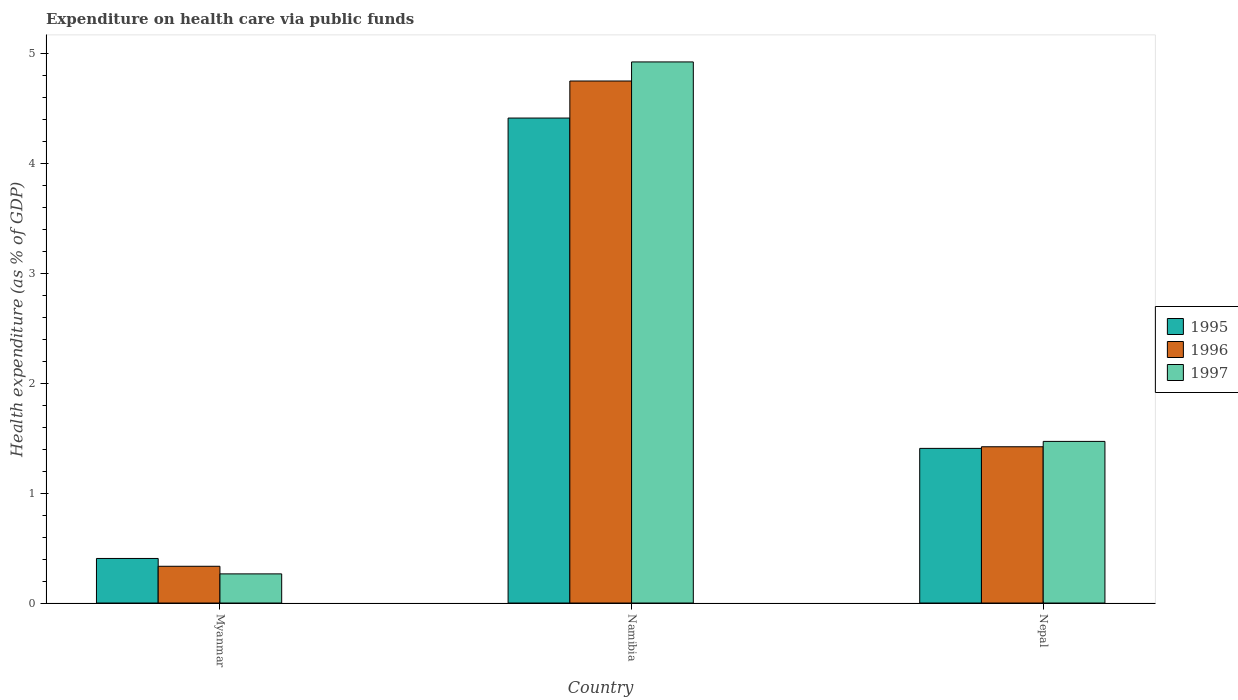Are the number of bars on each tick of the X-axis equal?
Ensure brevity in your answer.  Yes. How many bars are there on the 3rd tick from the right?
Your answer should be compact. 3. What is the label of the 1st group of bars from the left?
Your response must be concise. Myanmar. What is the expenditure made on health care in 1997 in Nepal?
Ensure brevity in your answer.  1.47. Across all countries, what is the maximum expenditure made on health care in 1996?
Make the answer very short. 4.75. Across all countries, what is the minimum expenditure made on health care in 1996?
Ensure brevity in your answer.  0.33. In which country was the expenditure made on health care in 1997 maximum?
Provide a succinct answer. Namibia. In which country was the expenditure made on health care in 1996 minimum?
Your answer should be compact. Myanmar. What is the total expenditure made on health care in 1995 in the graph?
Ensure brevity in your answer.  6.23. What is the difference between the expenditure made on health care in 1997 in Myanmar and that in Nepal?
Offer a very short reply. -1.21. What is the difference between the expenditure made on health care in 1995 in Nepal and the expenditure made on health care in 1996 in Myanmar?
Make the answer very short. 1.07. What is the average expenditure made on health care in 1996 per country?
Offer a terse response. 2.17. What is the difference between the expenditure made on health care of/in 1995 and expenditure made on health care of/in 1997 in Nepal?
Provide a succinct answer. -0.06. In how many countries, is the expenditure made on health care in 1996 greater than 2 %?
Provide a succinct answer. 1. What is the ratio of the expenditure made on health care in 1996 in Myanmar to that in Nepal?
Your answer should be very brief. 0.24. Is the expenditure made on health care in 1995 in Myanmar less than that in Nepal?
Provide a succinct answer. Yes. Is the difference between the expenditure made on health care in 1995 in Namibia and Nepal greater than the difference between the expenditure made on health care in 1997 in Namibia and Nepal?
Give a very brief answer. No. What is the difference between the highest and the second highest expenditure made on health care in 1996?
Ensure brevity in your answer.  -1.09. What is the difference between the highest and the lowest expenditure made on health care in 1996?
Provide a short and direct response. 4.42. In how many countries, is the expenditure made on health care in 1995 greater than the average expenditure made on health care in 1995 taken over all countries?
Ensure brevity in your answer.  1. What does the 3rd bar from the left in Namibia represents?
Provide a short and direct response. 1997. Is it the case that in every country, the sum of the expenditure made on health care in 1997 and expenditure made on health care in 1995 is greater than the expenditure made on health care in 1996?
Your answer should be compact. Yes. Are all the bars in the graph horizontal?
Your answer should be compact. No. How many countries are there in the graph?
Give a very brief answer. 3. What is the difference between two consecutive major ticks on the Y-axis?
Give a very brief answer. 1. Are the values on the major ticks of Y-axis written in scientific E-notation?
Your response must be concise. No. How many legend labels are there?
Provide a short and direct response. 3. What is the title of the graph?
Your answer should be very brief. Expenditure on health care via public funds. What is the label or title of the X-axis?
Offer a very short reply. Country. What is the label or title of the Y-axis?
Keep it short and to the point. Health expenditure (as % of GDP). What is the Health expenditure (as % of GDP) in 1995 in Myanmar?
Make the answer very short. 0.41. What is the Health expenditure (as % of GDP) of 1996 in Myanmar?
Keep it short and to the point. 0.33. What is the Health expenditure (as % of GDP) in 1997 in Myanmar?
Provide a succinct answer. 0.27. What is the Health expenditure (as % of GDP) of 1995 in Namibia?
Your response must be concise. 4.41. What is the Health expenditure (as % of GDP) in 1996 in Namibia?
Your answer should be compact. 4.75. What is the Health expenditure (as % of GDP) in 1997 in Namibia?
Offer a very short reply. 4.92. What is the Health expenditure (as % of GDP) in 1995 in Nepal?
Provide a succinct answer. 1.41. What is the Health expenditure (as % of GDP) in 1996 in Nepal?
Make the answer very short. 1.42. What is the Health expenditure (as % of GDP) in 1997 in Nepal?
Provide a succinct answer. 1.47. Across all countries, what is the maximum Health expenditure (as % of GDP) of 1995?
Offer a very short reply. 4.41. Across all countries, what is the maximum Health expenditure (as % of GDP) of 1996?
Give a very brief answer. 4.75. Across all countries, what is the maximum Health expenditure (as % of GDP) in 1997?
Keep it short and to the point. 4.92. Across all countries, what is the minimum Health expenditure (as % of GDP) of 1995?
Your response must be concise. 0.41. Across all countries, what is the minimum Health expenditure (as % of GDP) of 1996?
Your answer should be very brief. 0.33. Across all countries, what is the minimum Health expenditure (as % of GDP) in 1997?
Provide a short and direct response. 0.27. What is the total Health expenditure (as % of GDP) of 1995 in the graph?
Provide a succinct answer. 6.23. What is the total Health expenditure (as % of GDP) in 1996 in the graph?
Make the answer very short. 6.51. What is the total Health expenditure (as % of GDP) in 1997 in the graph?
Your response must be concise. 6.66. What is the difference between the Health expenditure (as % of GDP) of 1995 in Myanmar and that in Namibia?
Make the answer very short. -4.01. What is the difference between the Health expenditure (as % of GDP) of 1996 in Myanmar and that in Namibia?
Offer a very short reply. -4.42. What is the difference between the Health expenditure (as % of GDP) of 1997 in Myanmar and that in Namibia?
Give a very brief answer. -4.66. What is the difference between the Health expenditure (as % of GDP) of 1995 in Myanmar and that in Nepal?
Give a very brief answer. -1. What is the difference between the Health expenditure (as % of GDP) in 1996 in Myanmar and that in Nepal?
Your answer should be compact. -1.09. What is the difference between the Health expenditure (as % of GDP) in 1997 in Myanmar and that in Nepal?
Provide a short and direct response. -1.21. What is the difference between the Health expenditure (as % of GDP) of 1995 in Namibia and that in Nepal?
Make the answer very short. 3.01. What is the difference between the Health expenditure (as % of GDP) of 1996 in Namibia and that in Nepal?
Your response must be concise. 3.33. What is the difference between the Health expenditure (as % of GDP) of 1997 in Namibia and that in Nepal?
Provide a short and direct response. 3.45. What is the difference between the Health expenditure (as % of GDP) of 1995 in Myanmar and the Health expenditure (as % of GDP) of 1996 in Namibia?
Offer a terse response. -4.35. What is the difference between the Health expenditure (as % of GDP) of 1995 in Myanmar and the Health expenditure (as % of GDP) of 1997 in Namibia?
Make the answer very short. -4.52. What is the difference between the Health expenditure (as % of GDP) of 1996 in Myanmar and the Health expenditure (as % of GDP) of 1997 in Namibia?
Offer a terse response. -4.59. What is the difference between the Health expenditure (as % of GDP) of 1995 in Myanmar and the Health expenditure (as % of GDP) of 1996 in Nepal?
Give a very brief answer. -1.02. What is the difference between the Health expenditure (as % of GDP) in 1995 in Myanmar and the Health expenditure (as % of GDP) in 1997 in Nepal?
Make the answer very short. -1.07. What is the difference between the Health expenditure (as % of GDP) in 1996 in Myanmar and the Health expenditure (as % of GDP) in 1997 in Nepal?
Your answer should be compact. -1.14. What is the difference between the Health expenditure (as % of GDP) of 1995 in Namibia and the Health expenditure (as % of GDP) of 1996 in Nepal?
Offer a very short reply. 2.99. What is the difference between the Health expenditure (as % of GDP) in 1995 in Namibia and the Health expenditure (as % of GDP) in 1997 in Nepal?
Provide a succinct answer. 2.94. What is the difference between the Health expenditure (as % of GDP) in 1996 in Namibia and the Health expenditure (as % of GDP) in 1997 in Nepal?
Keep it short and to the point. 3.28. What is the average Health expenditure (as % of GDP) in 1995 per country?
Offer a very short reply. 2.08. What is the average Health expenditure (as % of GDP) of 1996 per country?
Provide a succinct answer. 2.17. What is the average Health expenditure (as % of GDP) in 1997 per country?
Your response must be concise. 2.22. What is the difference between the Health expenditure (as % of GDP) in 1995 and Health expenditure (as % of GDP) in 1996 in Myanmar?
Offer a very short reply. 0.07. What is the difference between the Health expenditure (as % of GDP) of 1995 and Health expenditure (as % of GDP) of 1997 in Myanmar?
Provide a succinct answer. 0.14. What is the difference between the Health expenditure (as % of GDP) of 1996 and Health expenditure (as % of GDP) of 1997 in Myanmar?
Make the answer very short. 0.07. What is the difference between the Health expenditure (as % of GDP) of 1995 and Health expenditure (as % of GDP) of 1996 in Namibia?
Offer a very short reply. -0.34. What is the difference between the Health expenditure (as % of GDP) in 1995 and Health expenditure (as % of GDP) in 1997 in Namibia?
Offer a very short reply. -0.51. What is the difference between the Health expenditure (as % of GDP) in 1996 and Health expenditure (as % of GDP) in 1997 in Namibia?
Provide a succinct answer. -0.17. What is the difference between the Health expenditure (as % of GDP) of 1995 and Health expenditure (as % of GDP) of 1996 in Nepal?
Keep it short and to the point. -0.01. What is the difference between the Health expenditure (as % of GDP) of 1995 and Health expenditure (as % of GDP) of 1997 in Nepal?
Keep it short and to the point. -0.06. What is the difference between the Health expenditure (as % of GDP) of 1996 and Health expenditure (as % of GDP) of 1997 in Nepal?
Make the answer very short. -0.05. What is the ratio of the Health expenditure (as % of GDP) in 1995 in Myanmar to that in Namibia?
Provide a succinct answer. 0.09. What is the ratio of the Health expenditure (as % of GDP) of 1996 in Myanmar to that in Namibia?
Give a very brief answer. 0.07. What is the ratio of the Health expenditure (as % of GDP) in 1997 in Myanmar to that in Namibia?
Your answer should be very brief. 0.05. What is the ratio of the Health expenditure (as % of GDP) of 1995 in Myanmar to that in Nepal?
Your answer should be very brief. 0.29. What is the ratio of the Health expenditure (as % of GDP) in 1996 in Myanmar to that in Nepal?
Keep it short and to the point. 0.24. What is the ratio of the Health expenditure (as % of GDP) in 1997 in Myanmar to that in Nepal?
Your answer should be compact. 0.18. What is the ratio of the Health expenditure (as % of GDP) in 1995 in Namibia to that in Nepal?
Your answer should be very brief. 3.14. What is the ratio of the Health expenditure (as % of GDP) of 1996 in Namibia to that in Nepal?
Provide a succinct answer. 3.34. What is the ratio of the Health expenditure (as % of GDP) in 1997 in Namibia to that in Nepal?
Give a very brief answer. 3.35. What is the difference between the highest and the second highest Health expenditure (as % of GDP) in 1995?
Make the answer very short. 3.01. What is the difference between the highest and the second highest Health expenditure (as % of GDP) of 1996?
Your answer should be very brief. 3.33. What is the difference between the highest and the second highest Health expenditure (as % of GDP) of 1997?
Your answer should be compact. 3.45. What is the difference between the highest and the lowest Health expenditure (as % of GDP) in 1995?
Provide a succinct answer. 4.01. What is the difference between the highest and the lowest Health expenditure (as % of GDP) of 1996?
Your response must be concise. 4.42. What is the difference between the highest and the lowest Health expenditure (as % of GDP) of 1997?
Provide a succinct answer. 4.66. 